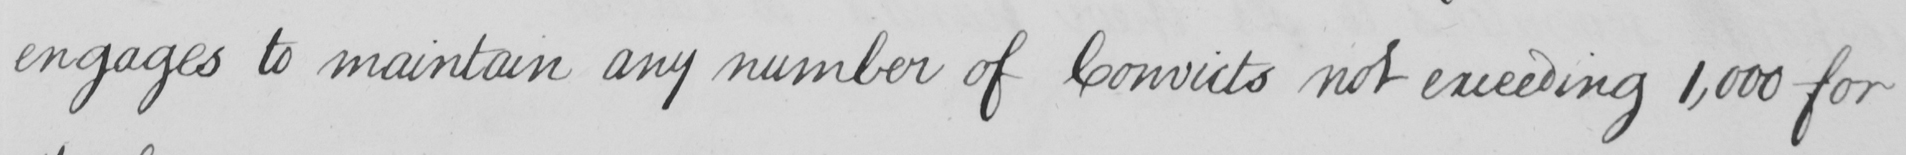Please transcribe the handwritten text in this image. engages to maintain any number of Convicts not exceeding 1,000 for 